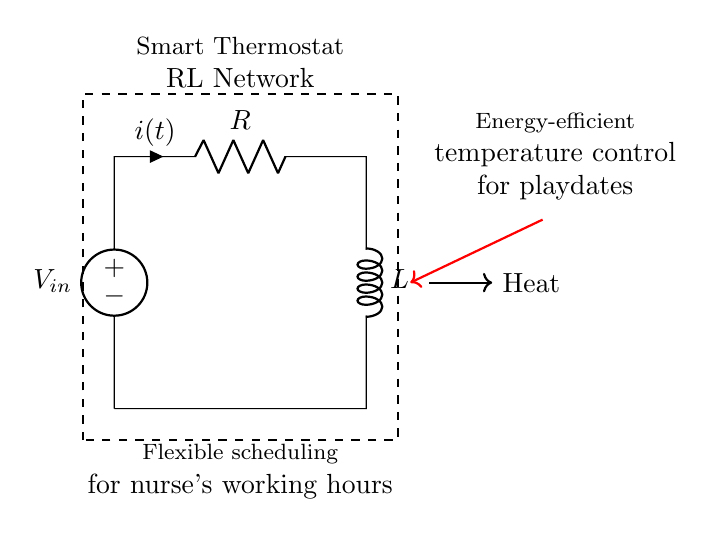What components are included in the RL network? The RL network consists of a resistor and an inductor, which are crucial for controlling the thermal energy in the smart thermostat. The diagram clearly labels these components as R for the resistor and L for the inductor.
Answer: Resistor and inductor What is the role of the voltage source in this circuit? The voltage source provides the electrical energy necessary for the circuit to function. It is the input voltage that powers the resistor-inductor network to maintain temperature control.
Answer: Power supply What is the current direction indicated in the circuit? The current direction, represented by the arrow, indicates that the current flows from the voltage source through the resistor and inductive component. This direction is important for understanding how energy is transferred in the circuit.
Answer: Clockwise How does the RL circuit contribute to energy efficiency in temperature control? The RL circuit allows for gradual changes in current and improves the response time of the thermostat. As the inductor stores energy and releases it slowly, it helps to minimize sudden spikes in temperature.
Answer: Gradual energy control What is the effect of increasing the resistance in this circuit? Increasing the resistance reduces the current flowing through the circuit based on Ohm's law. This can lead to less heating power, ultimately affecting how effectively the thermostat regulates the temperature.
Answer: Decreases current 